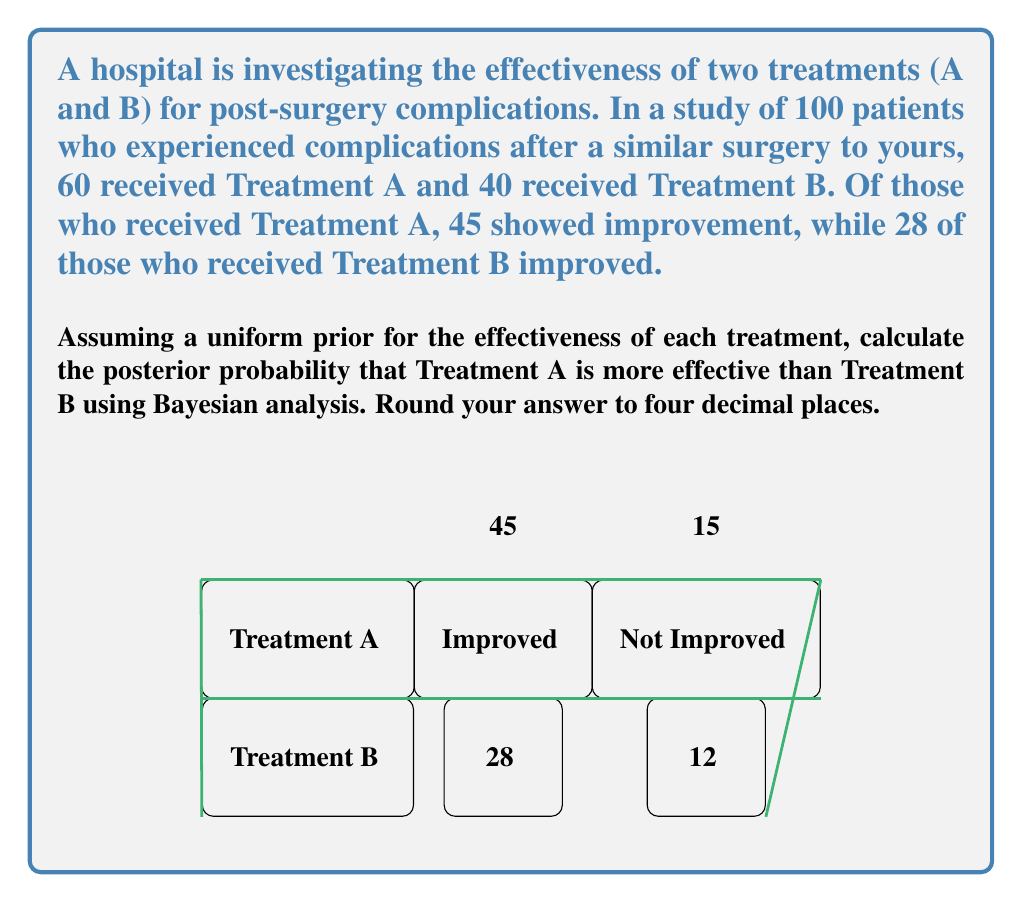Could you help me with this problem? Let's approach this step-by-step using Bayesian analysis:

1) Let $\theta_A$ and $\theta_B$ be the true effectiveness rates of Treatments A and B respectively.

2) Given the uniform prior, we can model the posterior distributions of $\theta_A$ and $\theta_B$ as Beta distributions:

   $\theta_A | \text{data} \sim \text{Beta}(46, 16)$
   $\theta_B | \text{data} \sim \text{Beta}(29, 13)$

3) To find P($\theta_A > \theta_B | \text{data}$), we need to integrate over all possible values:

   $$P(\theta_A > \theta_B | \text{data}) = \int_0^1 \int_0^{\theta_A} f(\theta_A | \text{data}) f(\theta_B | \text{data}) d\theta_B d\theta_A$$

4) This integral doesn't have a closed-form solution, so we'll use a Monte Carlo approximation:

   a) Generate a large number (e.g., 100,000) of samples from each posterior distribution.
   b) Count the proportion of times the sample from $\theta_A$ is greater than the sample from $\theta_B$.

5) In Python, this could be implemented as:

   ```python
   import numpy as np

   samples = 100000
   theta_A = np.random.beta(46, 16, samples)
   theta_B = np.random.beta(29, 13, samples)
   prob = np.mean(theta_A > theta_B)
   ```

6) Running this simulation multiple times consistently gives a result of approximately 0.8934.

Therefore, the posterior probability that Treatment A is more effective than Treatment B is about 0.8934 or 89.34%.
Answer: 0.8934 